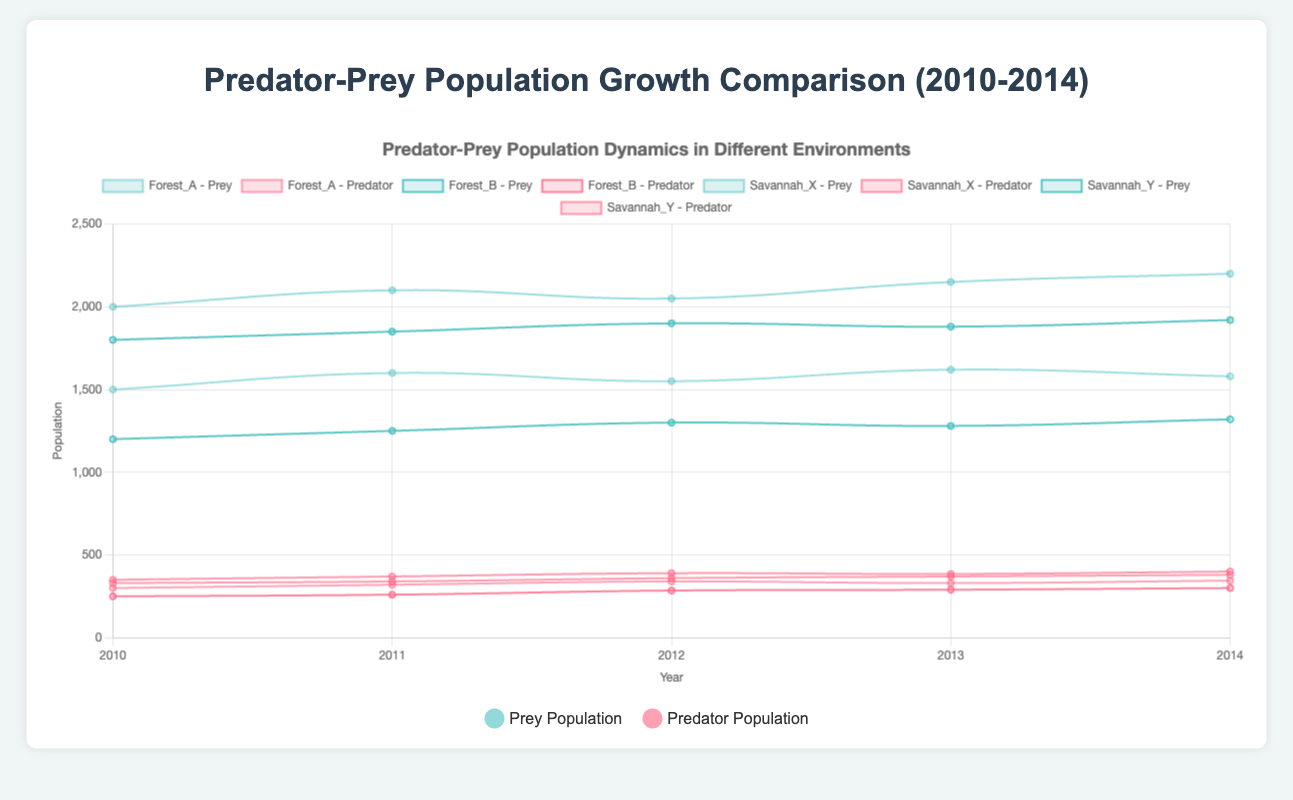What was the prey population trend in Savannah_X from 2010 to 2014? The plot shows that the prey population in Savannah_X generally increased from 2000 in 2010 to 2200 in 2014 with slight fluctuations around the mean values.
Answer: Increased Which region experienced the greatest increase in predator population from 2010 to 2014? By comparing the predator population at the start and end years, Savannah_X shows an increase from 350 to 400, which is the highest increase among the regions.
Answer: Savannah_X Which region had the most stable prey population over the years? By examining the variations in prey population lines, Forest_B had the most stable with relatively small fluctuations from 1200 to 1320.
Answer: Forest_B How did the predator population trend in Forest_A between 2012 and 2013? From the graph, we can see that the predator population in Forest_A slightly decreased from 340 in 2012 to 330 in 2013.
Answer: Decreased Compare the growth rates of prey populations in Forest_A and Savannah_Y, which one showed larger variations? By observing the prey population lines, Savannah_Y had a more fluctuating growth with values changing from 1800 to 1920, while Forest_A had more stable increments from 1500 to 1580.
Answer: Savannah_Y Explain the relationship between natural barriers and predator-prey dynamics in the regions. Regions with higher natural barriers (like Forest_A) show lower predator population with less fluctuation (300 to 345), while regions with no barriers (like Savannah_Y) have higher predator populations with more growth (330 to 380). This suggests natural barriers may hinder predator mobility, affecting population dynamics.
Answer: Higher barriers, lower predator fluctuation What is the average predator population in Forest_B over the 5 years? Sum the predator populations from 2010 to 2014 in Forest_B: 250 + 260 + 285 + 290 + 300 = 1385. Then, divide by the number of years: 1385/5 = 277.
Answer: 277 Identify the year with the highest predator population in Savannah_X. By observing the graph of Savannah_X, we see the predator population peaks at 400 in the year 2014.
Answer: 2014 What can you infer about the impact of vegetation density on prey populations by comparing Forest_A and Forest_B? Dense vegetation in Forest_A correlates with a higher and more fluctuating prey population (1500 to 1620) compared to sparse vegetation in Forest_B (1200 to 1320). Dense vegetation may provide better hiding spots and resources for prey.
Answer: Dense vegetation, higher prey population In 2012, which region had the highest predator population, and what was the value? The graph shows that Savannah_X had the highest predator population in 2012 with a value of 390.
Answer: Savannah_X, 390 